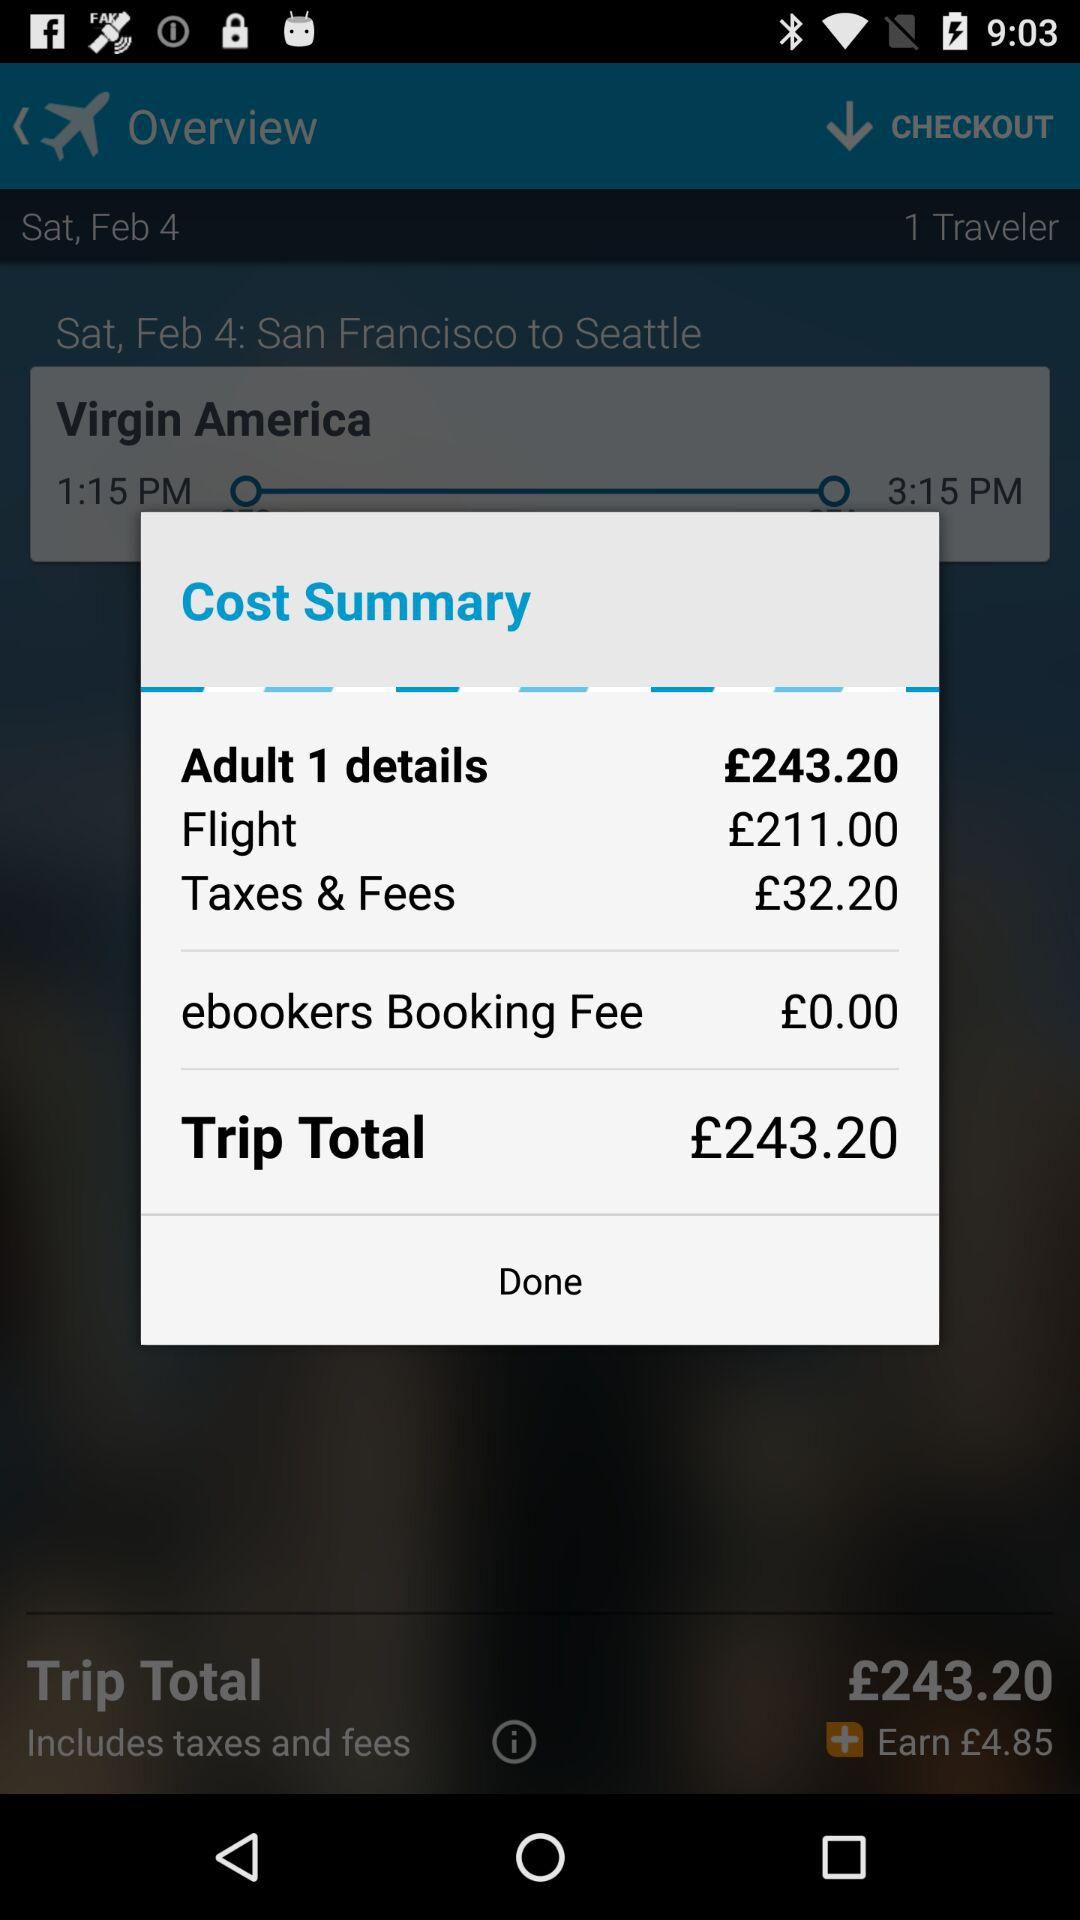How much is the ebookers booking fee?
Answer the question using a single word or phrase. £0.00 